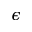Convert formula to latex. <formula><loc_0><loc_0><loc_500><loc_500>\epsilon</formula> 